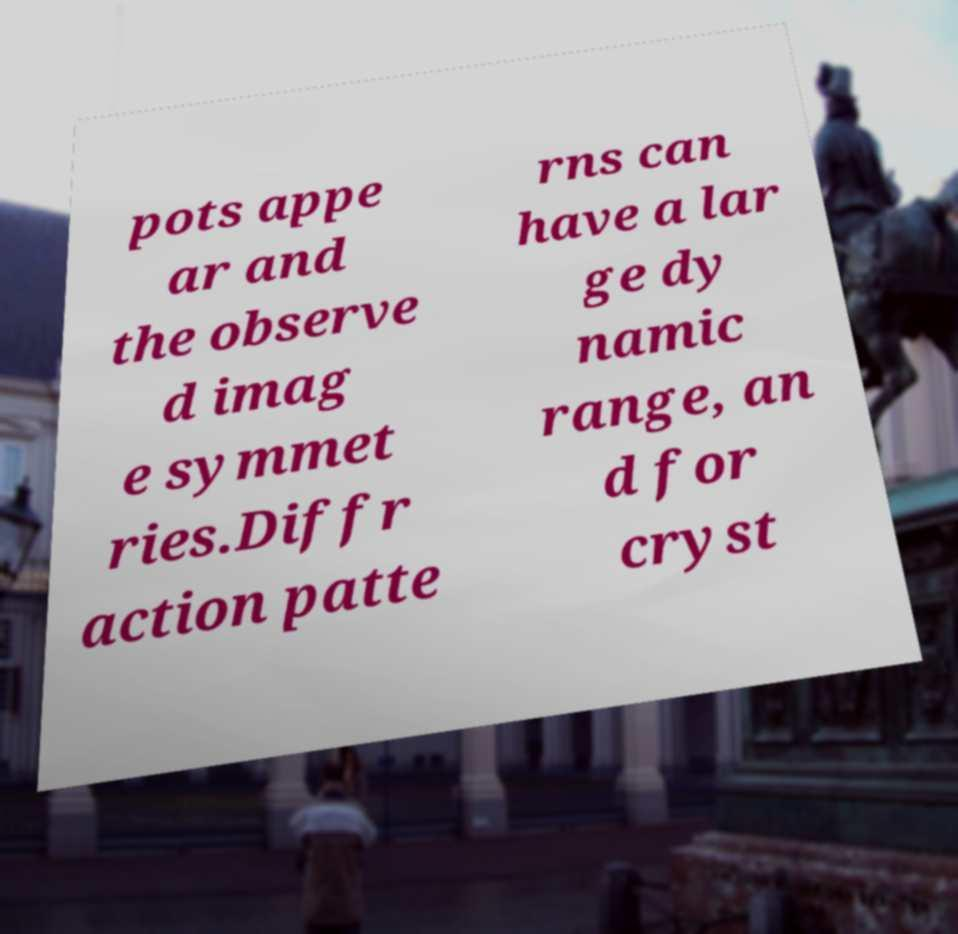Could you extract and type out the text from this image? pots appe ar and the observe d imag e symmet ries.Diffr action patte rns can have a lar ge dy namic range, an d for cryst 